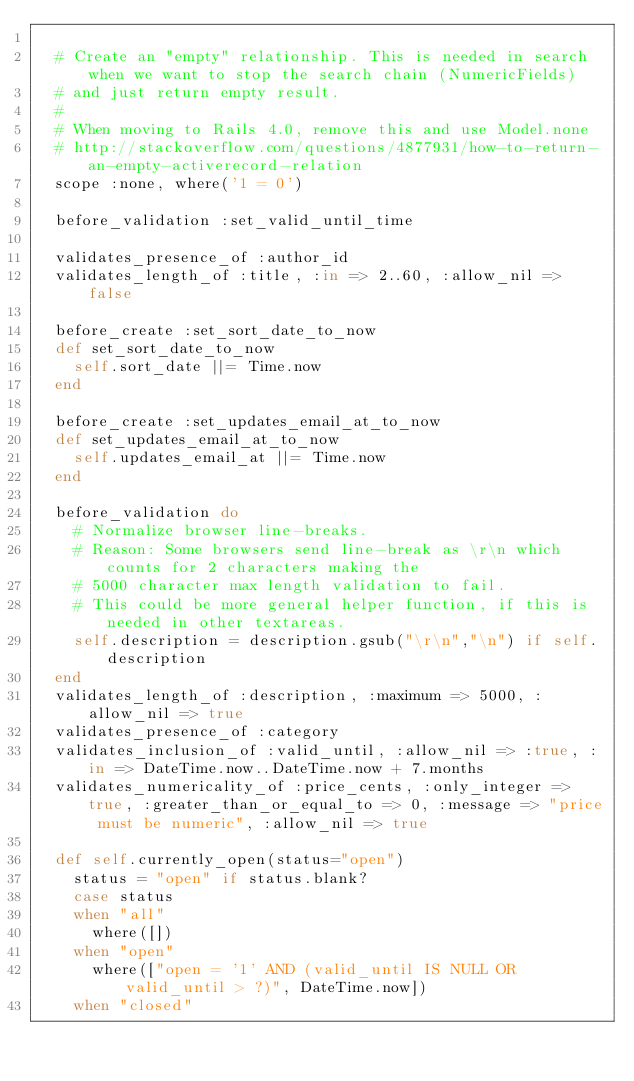Convert code to text. <code><loc_0><loc_0><loc_500><loc_500><_Ruby_>
  # Create an "empty" relationship. This is needed in search when we want to stop the search chain (NumericFields)
  # and just return empty result.
  #
  # When moving to Rails 4.0, remove this and use Model.none
  # http://stackoverflow.com/questions/4877931/how-to-return-an-empty-activerecord-relation
  scope :none, where('1 = 0')

  before_validation :set_valid_until_time

  validates_presence_of :author_id
  validates_length_of :title, :in => 2..60, :allow_nil => false

  before_create :set_sort_date_to_now
  def set_sort_date_to_now
    self.sort_date ||= Time.now
  end

  before_create :set_updates_email_at_to_now
  def set_updates_email_at_to_now
    self.updates_email_at ||= Time.now
  end

  before_validation do
    # Normalize browser line-breaks.
    # Reason: Some browsers send line-break as \r\n which counts for 2 characters making the
    # 5000 character max length validation to fail.
    # This could be more general helper function, if this is needed in other textareas.
    self.description = description.gsub("\r\n","\n") if self.description
  end
  validates_length_of :description, :maximum => 5000, :allow_nil => true
  validates_presence_of :category
  validates_inclusion_of :valid_until, :allow_nil => :true, :in => DateTime.now..DateTime.now + 7.months
  validates_numericality_of :price_cents, :only_integer => true, :greater_than_or_equal_to => 0, :message => "price must be numeric", :allow_nil => true

  def self.currently_open(status="open")
    status = "open" if status.blank?
    case status
    when "all"
      where([])
    when "open"
      where(["open = '1' AND (valid_until IS NULL OR valid_until > ?)", DateTime.now])
    when "closed"</code> 